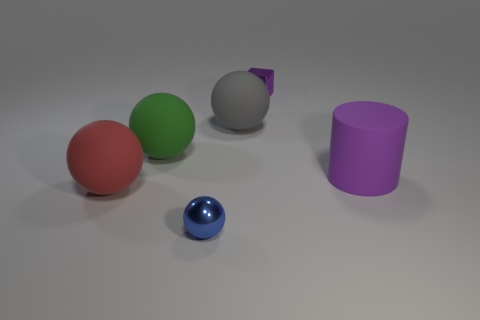How many other objects are there of the same material as the large gray thing?
Keep it short and to the point. 3. What shape is the thing that is both in front of the small purple block and behind the green thing?
Offer a terse response. Sphere. What is the color of the other tiny thing that is made of the same material as the tiny purple object?
Provide a succinct answer. Blue. Are there an equal number of gray rubber balls in front of the small purple metal block and blue shiny spheres?
Your response must be concise. Yes. What is the shape of the blue object that is the same size as the shiny cube?
Offer a very short reply. Sphere. What number of other things are the same shape as the green object?
Make the answer very short. 3. There is a red matte ball; is it the same size as the gray rubber sphere behind the large purple rubber object?
Your answer should be compact. Yes. What number of things are rubber objects that are in front of the large green object or purple blocks?
Provide a succinct answer. 3. What is the shape of the small object behind the big gray matte sphere?
Offer a terse response. Cube. Are there an equal number of big spheres right of the small block and tiny purple objects that are in front of the large cylinder?
Provide a succinct answer. Yes. 